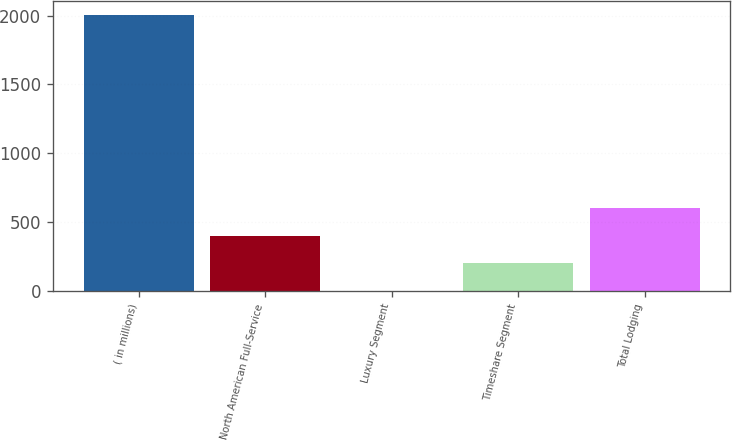Convert chart. <chart><loc_0><loc_0><loc_500><loc_500><bar_chart><fcel>( in millions)<fcel>North American Full-Service<fcel>Luxury Segment<fcel>Timeshare Segment<fcel>Total Lodging<nl><fcel>2004<fcel>403.2<fcel>3<fcel>203.1<fcel>603.3<nl></chart> 